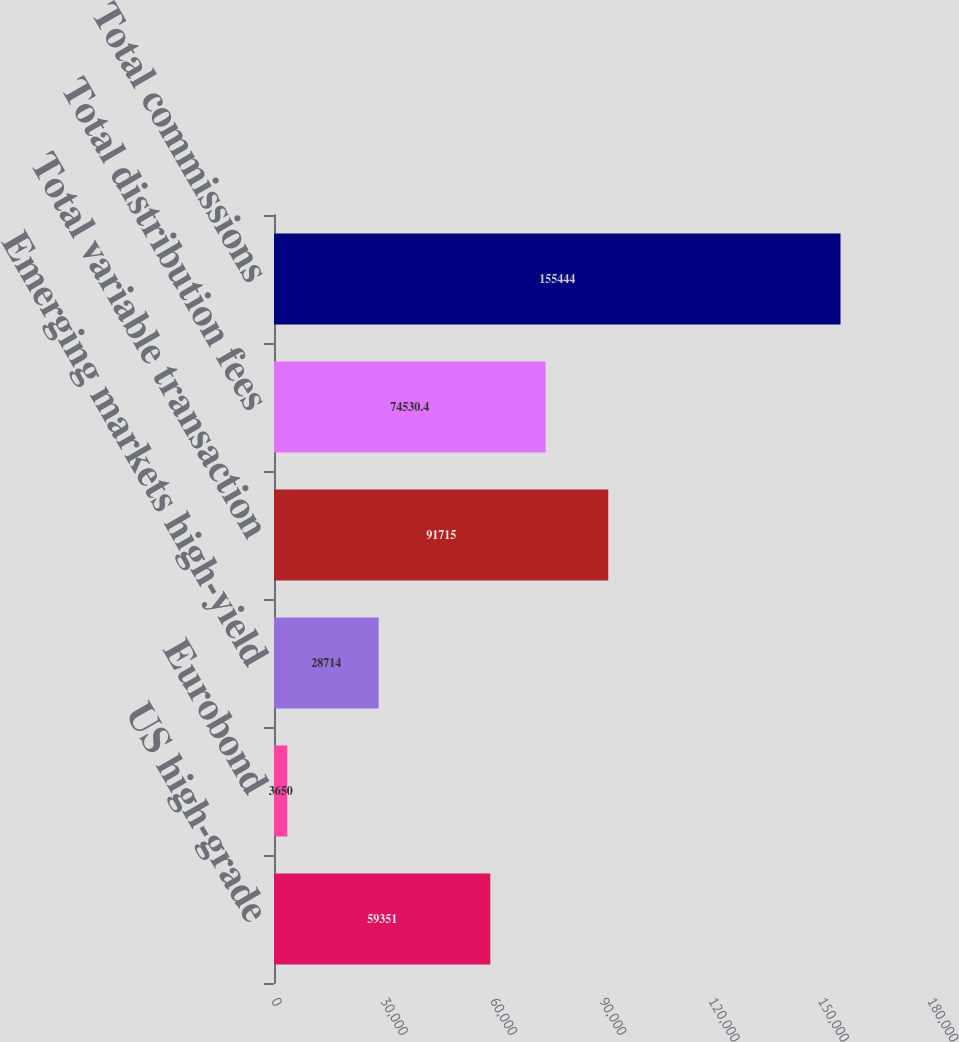<chart> <loc_0><loc_0><loc_500><loc_500><bar_chart><fcel>US high-grade<fcel>Eurobond<fcel>Emerging markets high-yield<fcel>Total variable transaction<fcel>Total distribution fees<fcel>Total commissions<nl><fcel>59351<fcel>3650<fcel>28714<fcel>91715<fcel>74530.4<fcel>155444<nl></chart> 